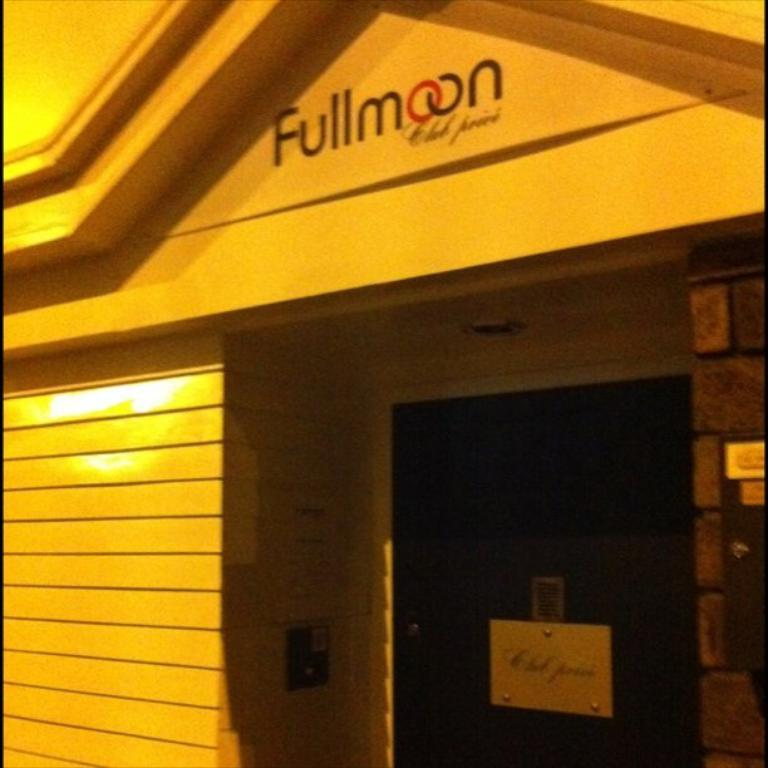What type of structure is present in the image? There is a building in the image. What can be seen on the building? The building has text on it. What is located near the door of the building? There is a board near the door. What can be found on the wall inside the building? There are objects on the wall. What type of lighting is present in the building? There is a light on the ceiling. What type of vegetable is being cooked on the stove in the image? There is no stove or vegetable present in the image. 